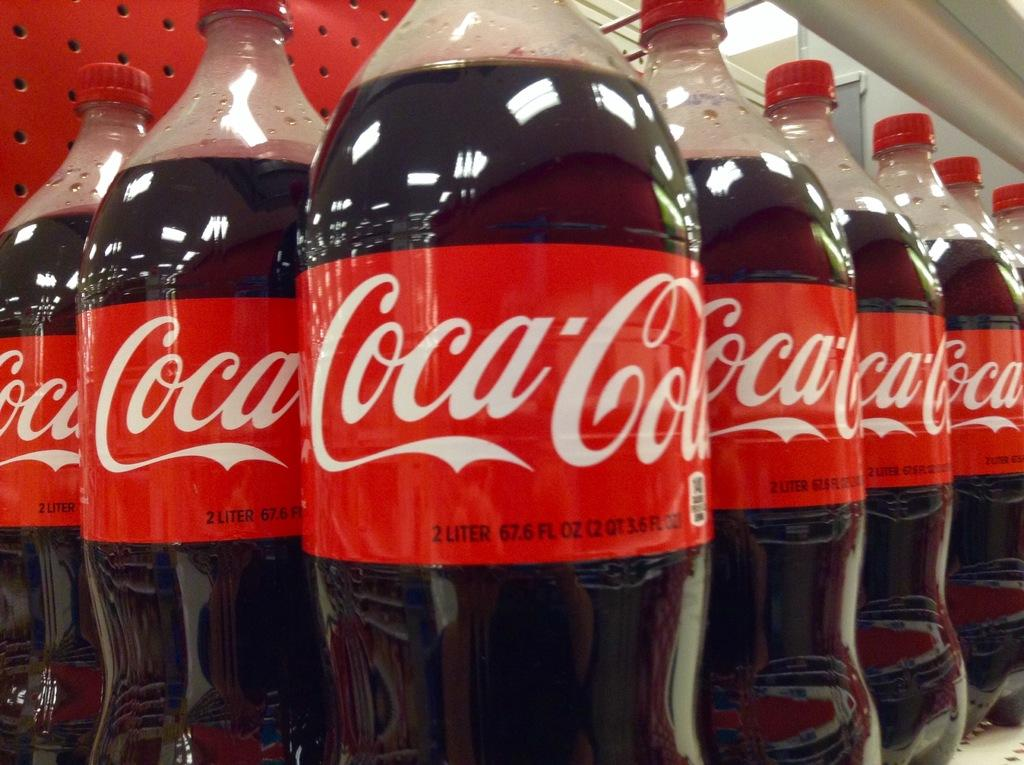What type of beverage is associated with the bottles in the image? The bottles in the image are associated with Coca-Cola, a soft drink. Can you see any caves in the image? There are no caves present in the image; it features coca-cola bottles. What type of hat is worn by the coca-cola bottles in the image? Coca-cola bottles do not wear hats, as they are inanimate objects. 